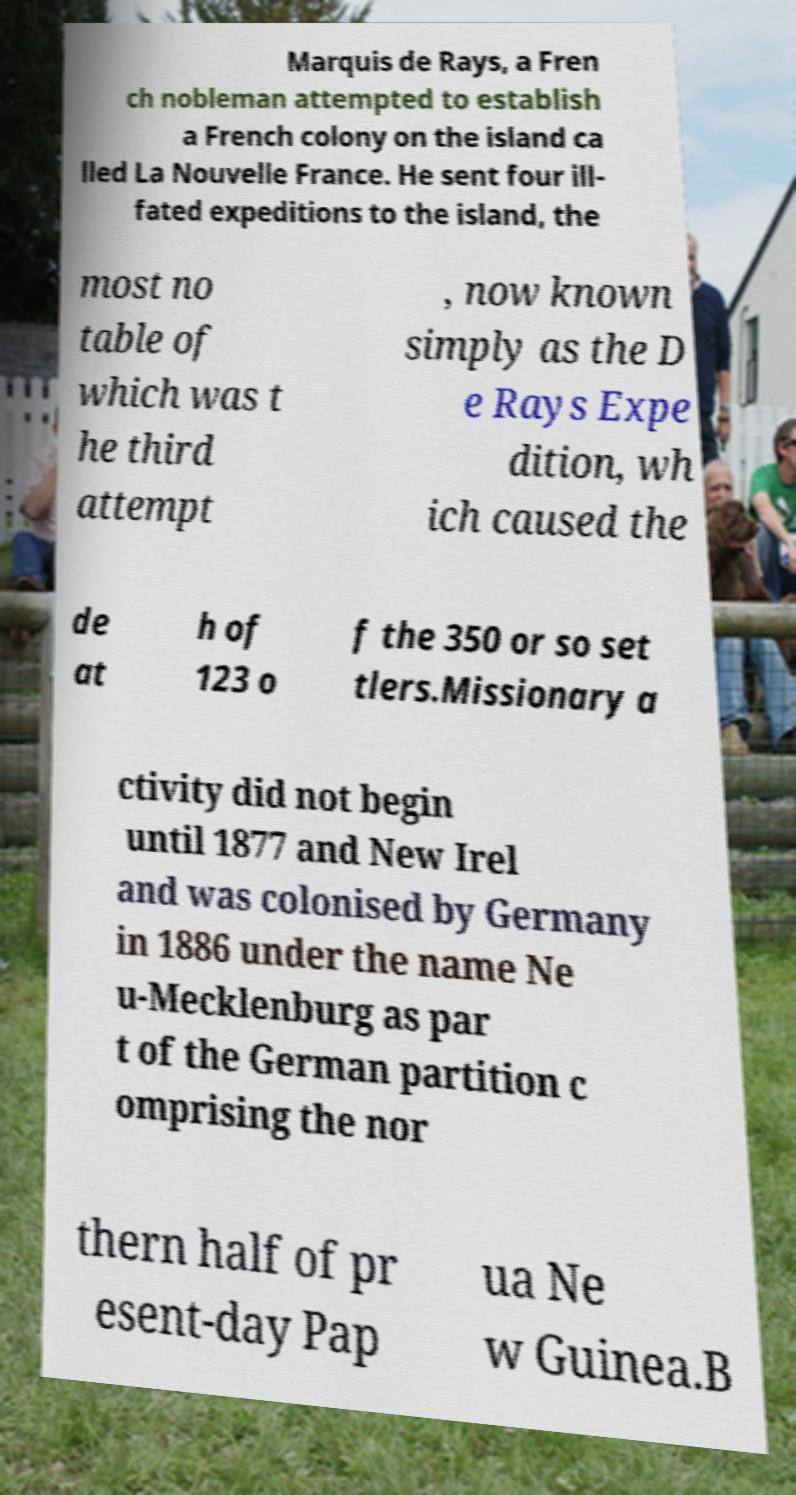Please read and relay the text visible in this image. What does it say? Marquis de Rays, a Fren ch nobleman attempted to establish a French colony on the island ca lled La Nouvelle France. He sent four ill- fated expeditions to the island, the most no table of which was t he third attempt , now known simply as the D e Rays Expe dition, wh ich caused the de at h of 123 o f the 350 or so set tlers.Missionary a ctivity did not begin until 1877 and New Irel and was colonised by Germany in 1886 under the name Ne u-Mecklenburg as par t of the German partition c omprising the nor thern half of pr esent-day Pap ua Ne w Guinea.B 